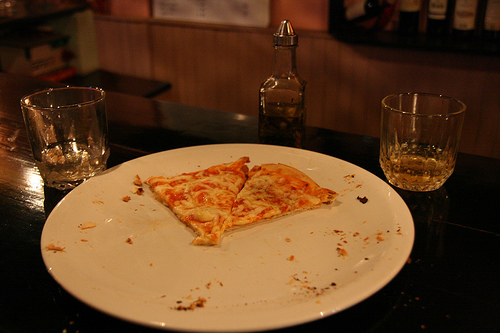Is the crust thin? Yes, the pizza features a thin crust, which is slightly crisp around the edges, characteristic of a classic thin crust pizza. 